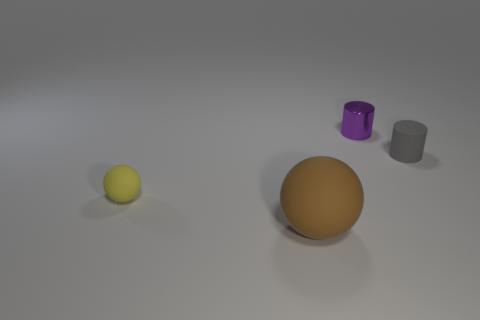What number of other objects are the same color as the metal object?
Your response must be concise. 0. How many yellow objects are small matte objects or small matte balls?
Your answer should be very brief. 1. Does the brown object have the same shape as the small thing that is behind the gray object?
Give a very brief answer. No. What is the shape of the yellow thing?
Offer a very short reply. Sphere. There is a yellow thing that is the same size as the gray cylinder; what material is it?
Keep it short and to the point. Rubber. Is there any other thing that has the same size as the brown object?
Your answer should be very brief. No. How many objects are either small matte objects or purple objects right of the large matte sphere?
Your answer should be very brief. 3. There is a brown ball that is made of the same material as the gray thing; what is its size?
Keep it short and to the point. Large. There is a tiny matte thing that is to the left of the small matte cylinder that is on the right side of the small purple metallic cylinder; what is its shape?
Provide a short and direct response. Sphere. There is a thing that is both right of the big rubber sphere and on the left side of the tiny gray object; how big is it?
Give a very brief answer. Small. 